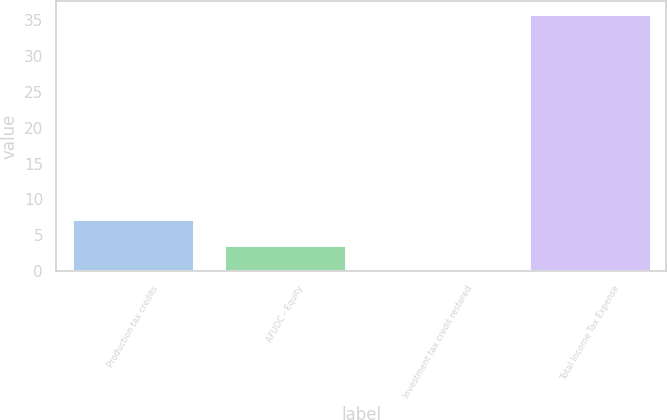<chart> <loc_0><loc_0><loc_500><loc_500><bar_chart><fcel>Production tax credits<fcel>AFUDC - Equity<fcel>Investment tax credit restored<fcel>Total Income Tax Expense<nl><fcel>7.26<fcel>3.68<fcel>0.1<fcel>35.9<nl></chart> 